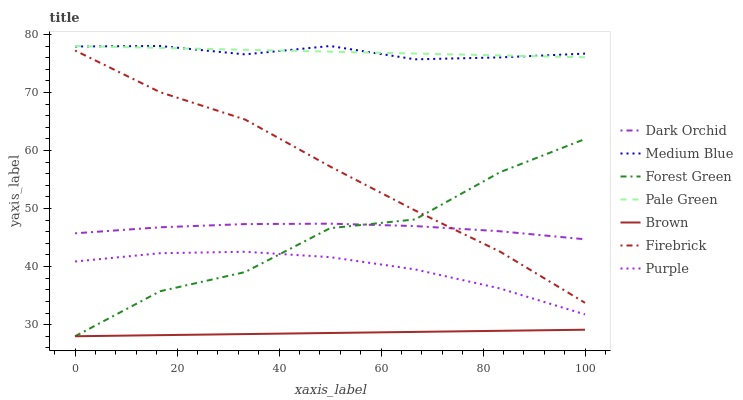Does Brown have the minimum area under the curve?
Answer yes or no. Yes. Does Pale Green have the maximum area under the curve?
Answer yes or no. Yes. Does Purple have the minimum area under the curve?
Answer yes or no. No. Does Purple have the maximum area under the curve?
Answer yes or no. No. Is Brown the smoothest?
Answer yes or no. Yes. Is Forest Green the roughest?
Answer yes or no. Yes. Is Purple the smoothest?
Answer yes or no. No. Is Purple the roughest?
Answer yes or no. No. Does Brown have the lowest value?
Answer yes or no. Yes. Does Purple have the lowest value?
Answer yes or no. No. Does Pale Green have the highest value?
Answer yes or no. Yes. Does Purple have the highest value?
Answer yes or no. No. Is Dark Orchid less than Medium Blue?
Answer yes or no. Yes. Is Pale Green greater than Dark Orchid?
Answer yes or no. Yes. Does Purple intersect Forest Green?
Answer yes or no. Yes. Is Purple less than Forest Green?
Answer yes or no. No. Is Purple greater than Forest Green?
Answer yes or no. No. Does Dark Orchid intersect Medium Blue?
Answer yes or no. No. 